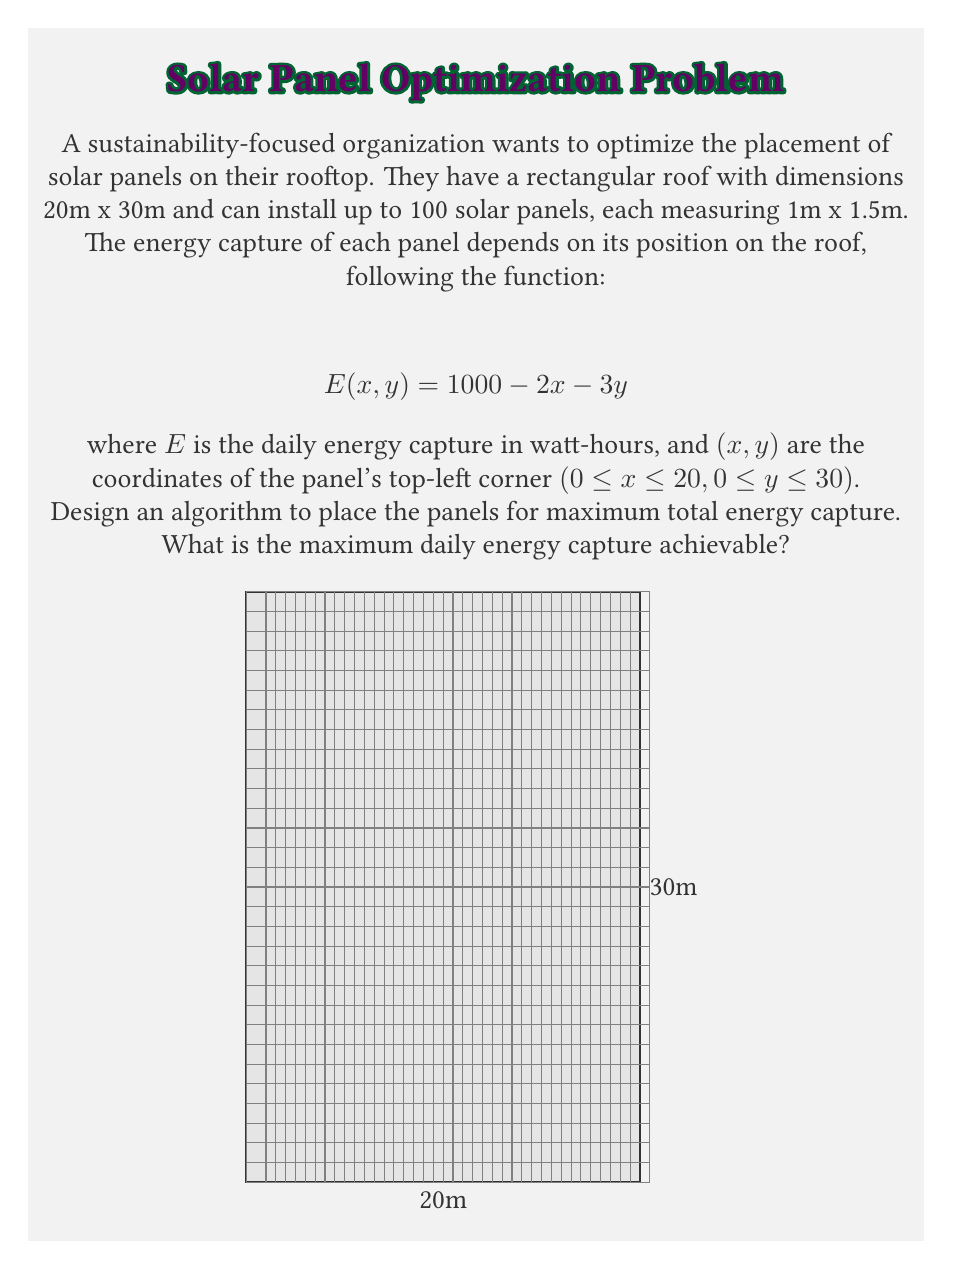Provide a solution to this math problem. To solve this problem, we need to follow these steps:

1) Observe that the energy capture function $E(x, y) = 1000 - 2x - 3y$ decreases as x and y increase. This means the panels should be placed starting from the top-left corner (0, 0) of the roof for maximum energy capture.

2) Calculate how many panels can fit in each row and column:
   - Rows: 30m / 1.5m = 20 panels
   - Columns: 20m / 1m = 20 panels

3) We can place 20 x 20 = 400 panels on the roof, but we're limited to 100 panels. So we'll fill the top-left corner with 100 panels.

4) To maximize energy capture, we should place panels in a 10 x 10 grid starting from (0, 0).

5) Calculate the energy capture for each panel:
   For panel at position (i, j) where 0 ≤ i, j ≤ 9:
   $$E(i, j) = 1000 - 2i - 3j$$

6) Sum the energy capture for all 100 panels:

   $$\text{Total Energy} = \sum_{i=0}^9 \sum_{j=0}^9 (1000 - 2i - 3j)$$

7) This sum can be calculated as:
   $$\text{Total Energy} = 100000 - 2 \sum_{i=0}^9 (10i) - 3 \sum_{j=0}^9 (10j)$$
   $$= 100000 - 2(450) - 3(450)$$
   $$= 100000 - 900 - 1350$$
   $$= 97750 \text{ watt-hours}$$

Therefore, the maximum daily energy capture achievable is 97,750 watt-hours.
Answer: 97,750 watt-hours 